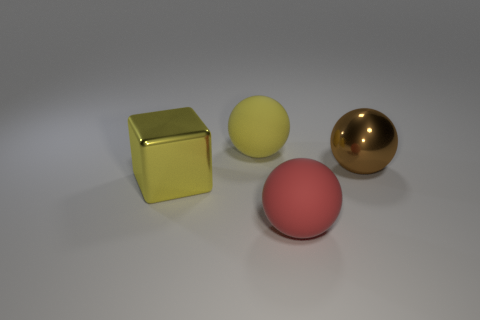Add 3 yellow spheres. How many objects exist? 7 Subtract all blocks. How many objects are left? 3 Add 2 big brown things. How many big brown things are left? 3 Add 2 red cubes. How many red cubes exist? 2 Subtract 0 purple cylinders. How many objects are left? 4 Subtract all large red matte spheres. Subtract all brown metal spheres. How many objects are left? 2 